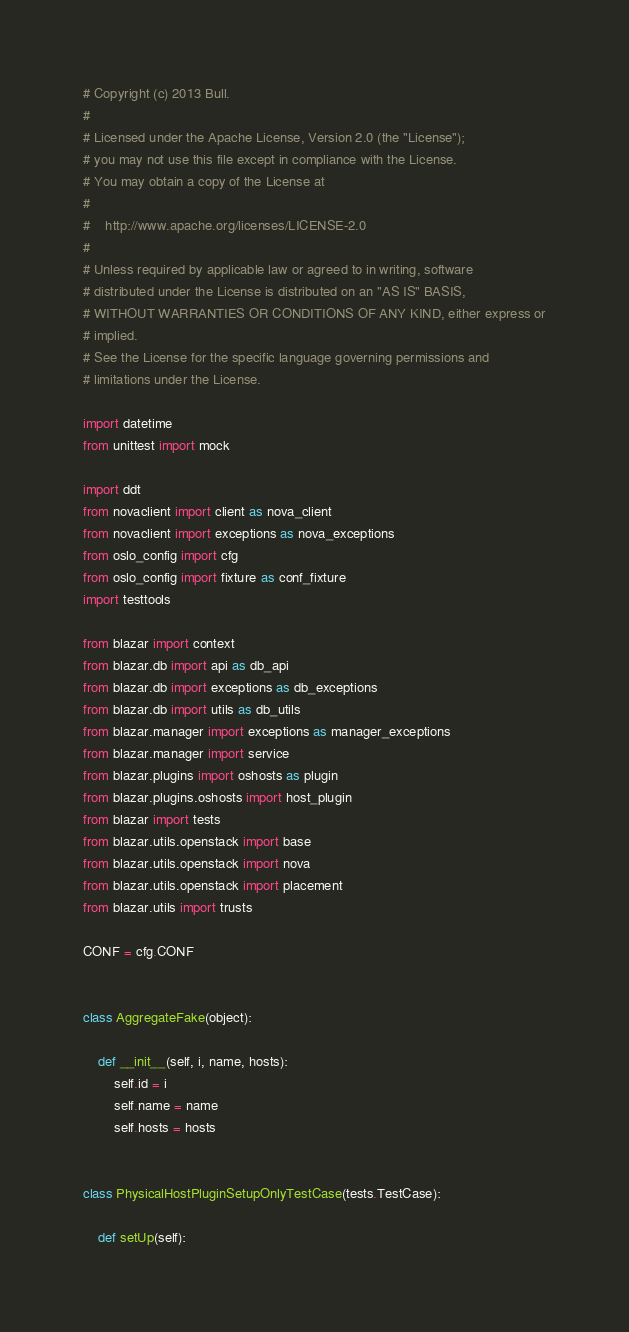Convert code to text. <code><loc_0><loc_0><loc_500><loc_500><_Python_># Copyright (c) 2013 Bull.
#
# Licensed under the Apache License, Version 2.0 (the "License");
# you may not use this file except in compliance with the License.
# You may obtain a copy of the License at
#
#    http://www.apache.org/licenses/LICENSE-2.0
#
# Unless required by applicable law or agreed to in writing, software
# distributed under the License is distributed on an "AS IS" BASIS,
# WITHOUT WARRANTIES OR CONDITIONS OF ANY KIND, either express or
# implied.
# See the License for the specific language governing permissions and
# limitations under the License.

import datetime
from unittest import mock

import ddt
from novaclient import client as nova_client
from novaclient import exceptions as nova_exceptions
from oslo_config import cfg
from oslo_config import fixture as conf_fixture
import testtools

from blazar import context
from blazar.db import api as db_api
from blazar.db import exceptions as db_exceptions
from blazar.db import utils as db_utils
from blazar.manager import exceptions as manager_exceptions
from blazar.manager import service
from blazar.plugins import oshosts as plugin
from blazar.plugins.oshosts import host_plugin
from blazar import tests
from blazar.utils.openstack import base
from blazar.utils.openstack import nova
from blazar.utils.openstack import placement
from blazar.utils import trusts

CONF = cfg.CONF


class AggregateFake(object):

    def __init__(self, i, name, hosts):
        self.id = i
        self.name = name
        self.hosts = hosts


class PhysicalHostPluginSetupOnlyTestCase(tests.TestCase):

    def setUp(self):</code> 